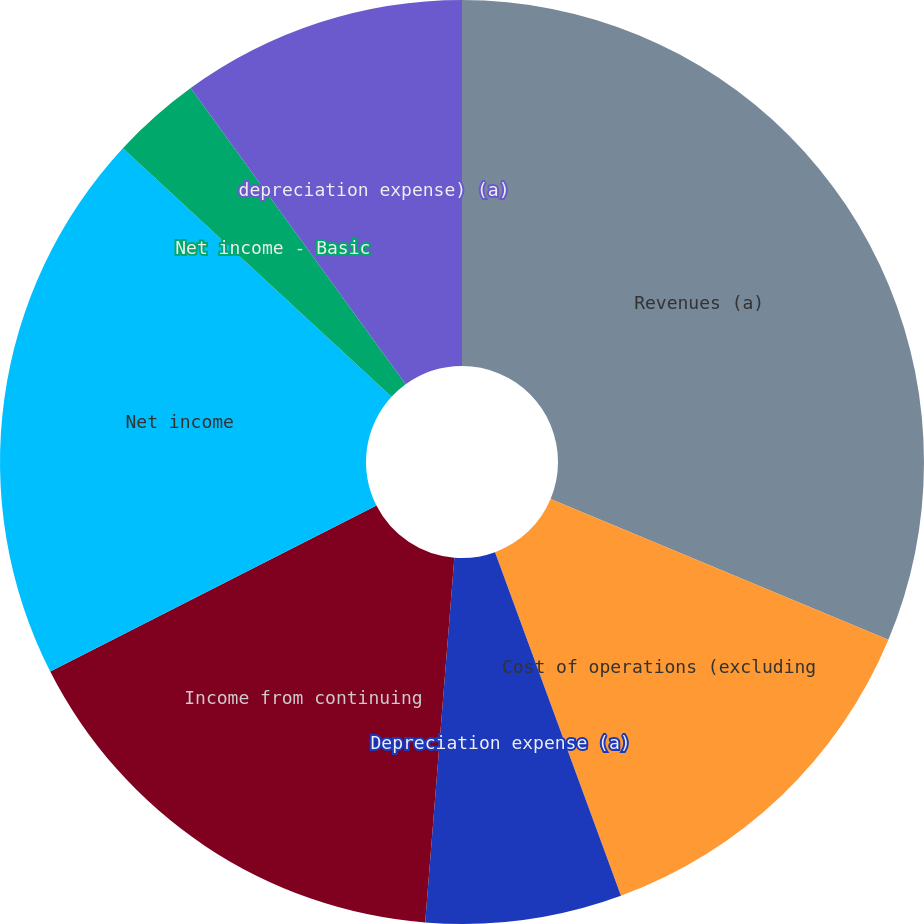Convert chart to OTSL. <chart><loc_0><loc_0><loc_500><loc_500><pie_chart><fcel>Revenues (a)<fcel>Cost of operations (excluding<fcel>Depreciation expense (a)<fcel>Income from continuing<fcel>Net income<fcel>Net income - Basic<fcel>Net income - Diluted<fcel>depreciation expense) (a)<nl><fcel>31.29%<fcel>13.12%<fcel>6.86%<fcel>16.24%<fcel>19.37%<fcel>3.13%<fcel>0.0%<fcel>9.99%<nl></chart> 